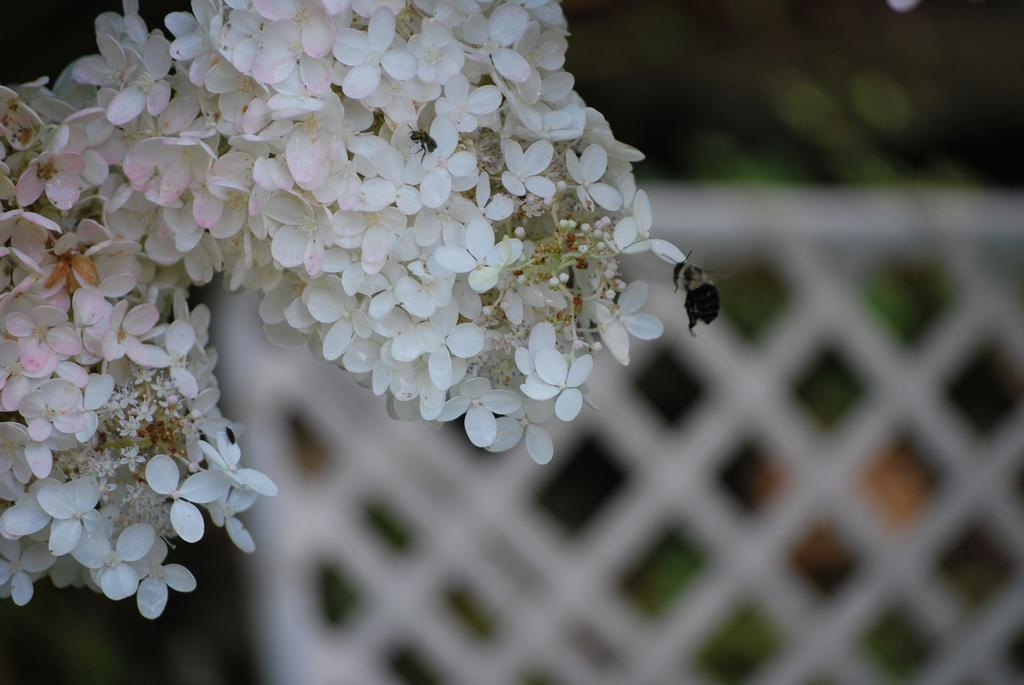What is the main subject of the image? The main subject of the image is flowers. Can you describe the flowers in more detail? There are buds on stems in the image. Are there any living organisms present in the image? Yes, there are two insects in the image. What else can be seen in the image besides flowers and insects? There are plants and a white fence in the image. What type of bear can be seen interacting with the fence in the image? There is no bear present in the image; it features flowers, insects, plants, and a white fence. Can you tell me who the owner of the fence is in the image? There is no information about the owner of the fence in the image. 